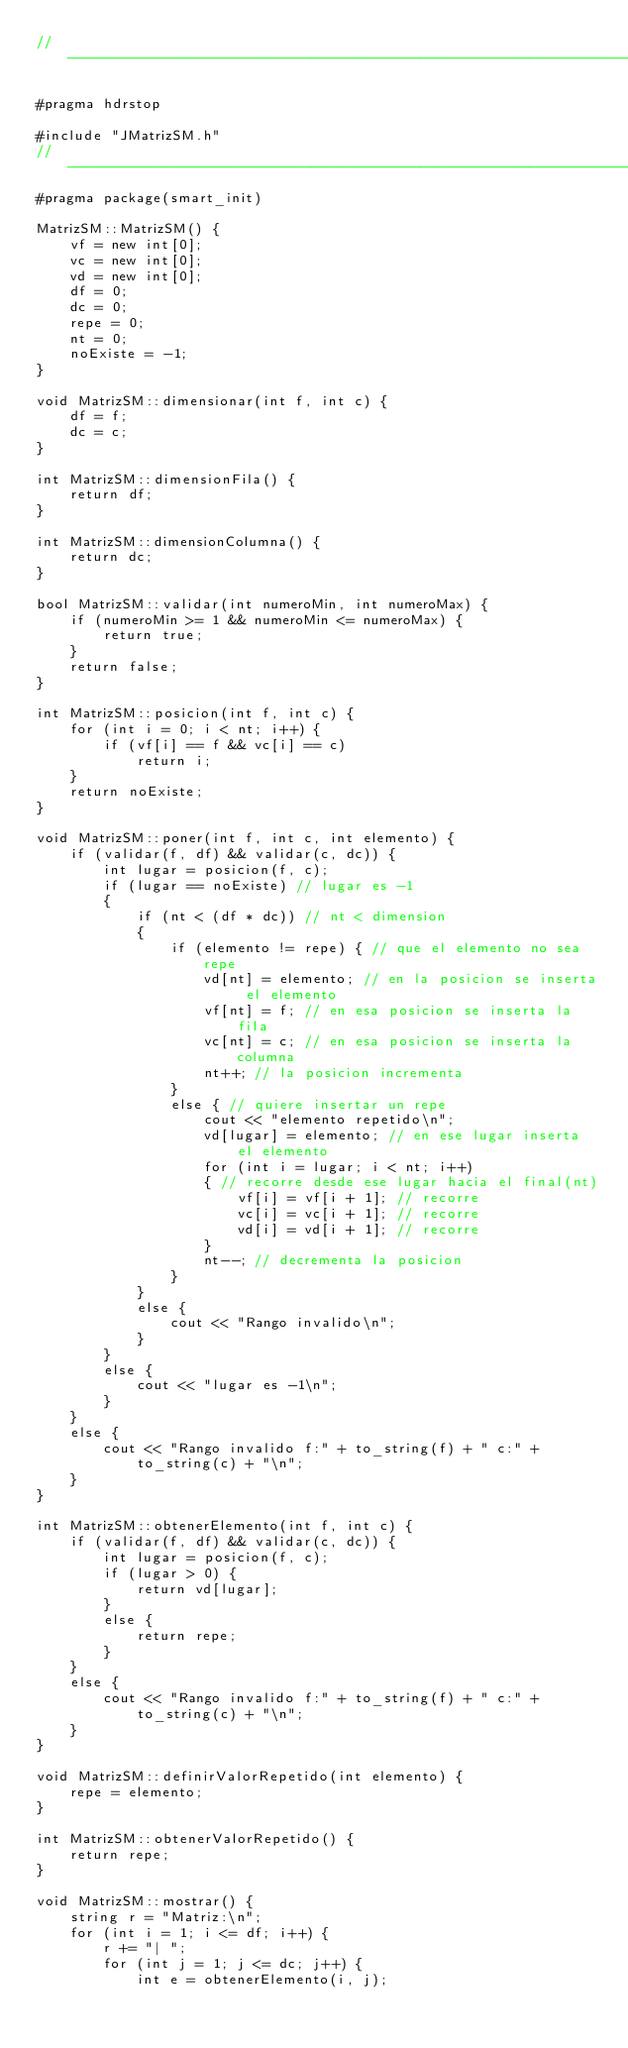<code> <loc_0><loc_0><loc_500><loc_500><_C++_>// ---------------------------------------------------------------------------

#pragma hdrstop

#include "JMatrizSM.h"
// ---------------------------------------------------------------------------
#pragma package(smart_init)

MatrizSM::MatrizSM() {
	vf = new int[0];
	vc = new int[0];
	vd = new int[0];
	df = 0;
	dc = 0;
	repe = 0;
	nt = 0;
	noExiste = -1;
}

void MatrizSM::dimensionar(int f, int c) {
	df = f;
	dc = c;
}

int MatrizSM::dimensionFila() {
	return df;
}

int MatrizSM::dimensionColumna() {
	return dc;
}

bool MatrizSM::validar(int numeroMin, int numeroMax) {
	if (numeroMin >= 1 && numeroMin <= numeroMax) {
		return true;
	}
	return false;
}

int MatrizSM::posicion(int f, int c) {
	for (int i = 0; i < nt; i++) {
		if (vf[i] == f && vc[i] == c)
			return i;
	}
	return noExiste;
}

void MatrizSM::poner(int f, int c, int elemento) {
	if (validar(f, df) && validar(c, dc)) {
		int lugar = posicion(f, c);
		if (lugar == noExiste) // lugar es -1
		{
			if (nt < (df * dc)) // nt < dimension
			{
				if (elemento != repe) { // que el elemento no sea repe
					vd[nt] = elemento; // en la posicion se inserta el elemento
					vf[nt] = f; // en esa posicion se inserta la fila
					vc[nt] = c; // en esa posicion se inserta la columna
					nt++; // la posicion incrementa
				}
				else { // quiere insertar un repe
					cout << "elemento repetido\n";
					vd[lugar] = elemento; // en ese lugar inserta el elemento
					for (int i = lugar; i < nt; i++)
					{ // recorre desde ese lugar hacia el final(nt)
						vf[i] = vf[i + 1]; // recorre
						vc[i] = vc[i + 1]; // recorre
						vd[i] = vd[i + 1]; // recorre
					}
					nt--; // decrementa la posicion
				}
			}
			else {
				cout << "Rango invalido\n";
			}
		}
		else {
			cout << "lugar es -1\n";
		}
	}
	else {
		cout << "Rango invalido f:" + to_string(f) + " c:" +
			to_string(c) + "\n";
	}
}

int MatrizSM::obtenerElemento(int f, int c) {
	if (validar(f, df) && validar(c, dc)) {
		int lugar = posicion(f, c);
		if (lugar > 0) {
			return vd[lugar];
		}
		else {
			return repe;
		}
	}
	else {
		cout << "Rango invalido f:" + to_string(f) + " c:" +
			to_string(c) + "\n";
	}
}

void MatrizSM::definirValorRepetido(int elemento) {
	repe = elemento;
}

int MatrizSM::obtenerValorRepetido() {
	return repe;
}

void MatrizSM::mostrar() {
	string r = "Matriz:\n";
	for (int i = 1; i <= df; i++) {
		r += "| ";
		for (int j = 1; j <= dc; j++) {
			int e = obtenerElemento(i, j);</code> 